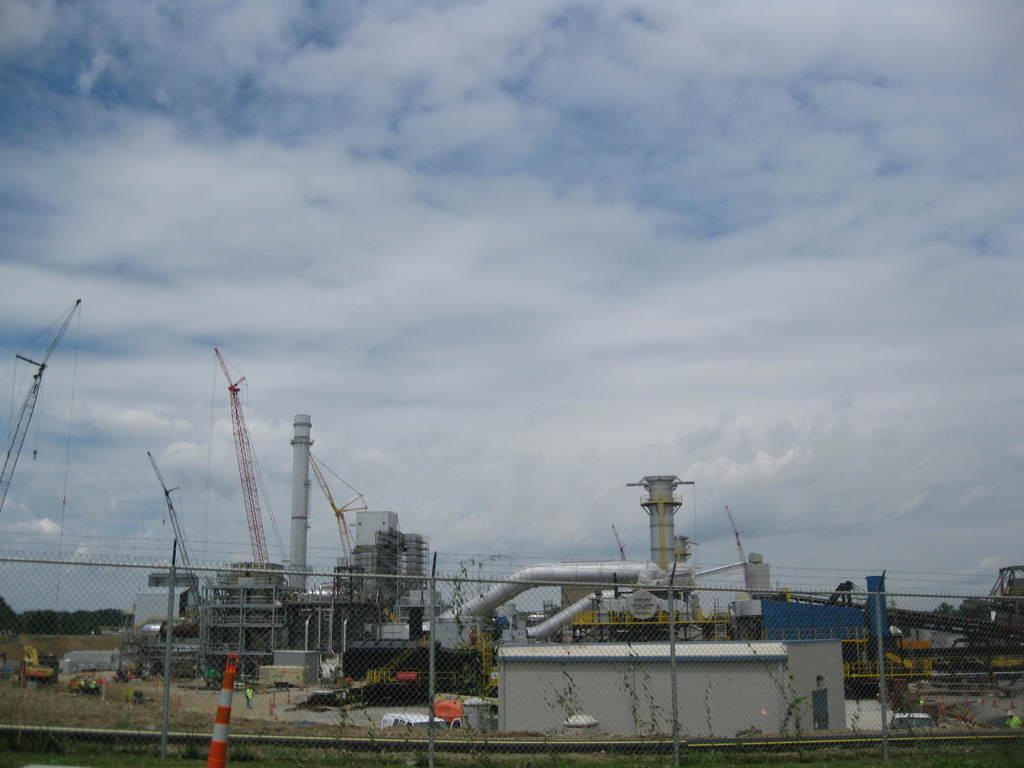In one or two sentences, can you explain what this image depicts? In the picture I can see buildings, pipe, factory, fence, poles and some other objects on the ground. In the background I can see trees and the sky. 